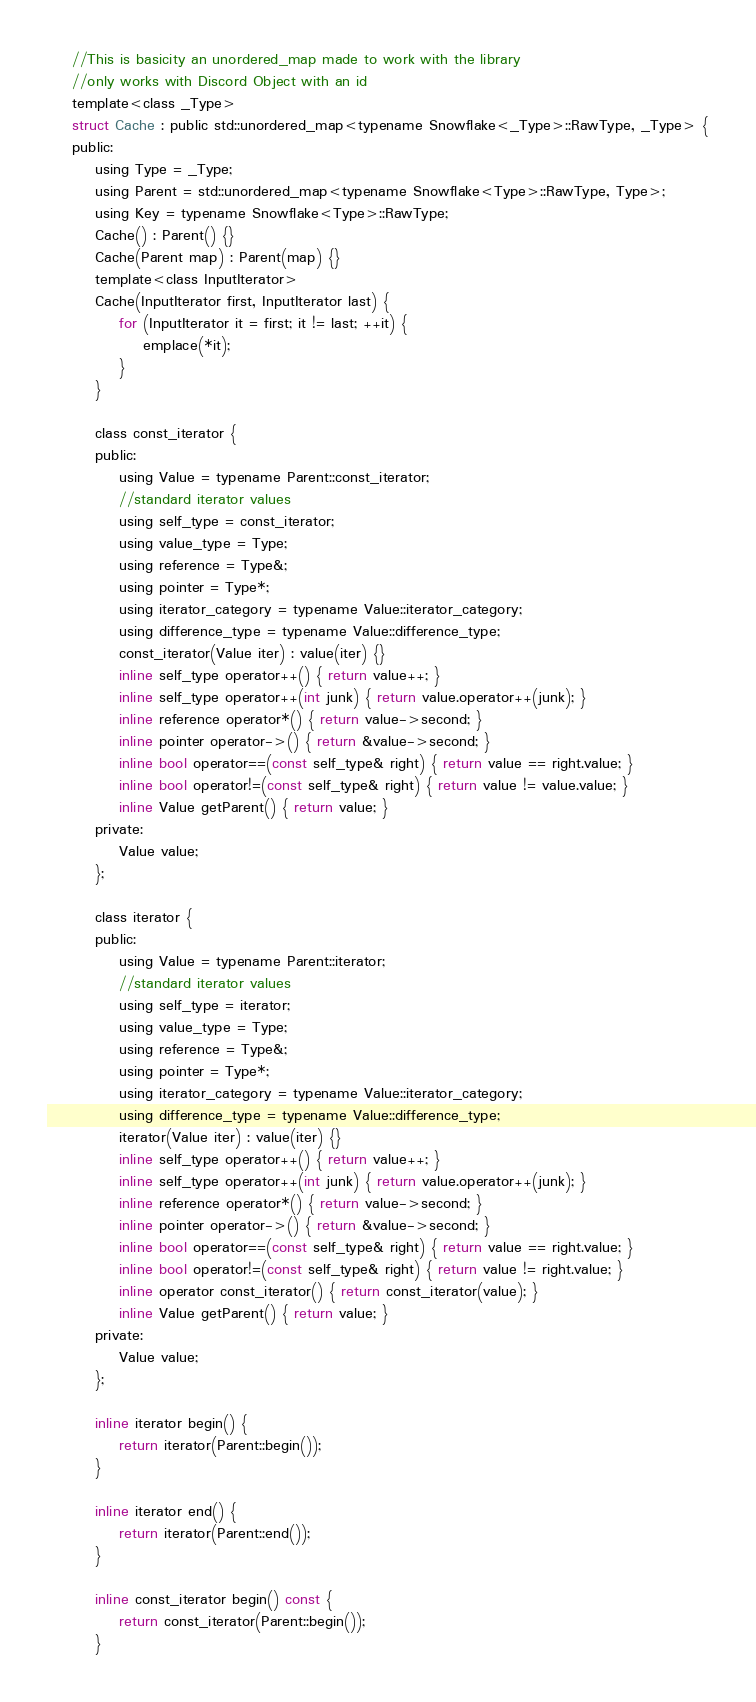Convert code to text. <code><loc_0><loc_0><loc_500><loc_500><_C_>	//This is basicity an unordered_map made to work with the library
	//only works with Discord Object with an id
	template<class _Type>
	struct Cache : public std::unordered_map<typename Snowflake<_Type>::RawType, _Type> {
	public:
		using Type = _Type;
		using Parent = std::unordered_map<typename Snowflake<Type>::RawType, Type>;
		using Key = typename Snowflake<Type>::RawType;
		Cache() : Parent() {}
		Cache(Parent map) : Parent(map) {}
		template<class InputIterator>
		Cache(InputIterator first, InputIterator last) {
			for (InputIterator it = first; it != last; ++it) {
				emplace(*it);
			}
		}

		class const_iterator {
		public:
			using Value = typename Parent::const_iterator;
			//standard iterator values
			using self_type = const_iterator;
			using value_type = Type;
			using reference = Type&;
			using pointer = Type*;
			using iterator_category = typename Value::iterator_category;
			using difference_type = typename Value::difference_type;
			const_iterator(Value iter) : value(iter) {}
			inline self_type operator++() { return value++; }
			inline self_type operator++(int junk) { return value.operator++(junk); }
			inline reference operator*() { return value->second; }
			inline pointer operator->() { return &value->second; }
			inline bool operator==(const self_type& right) { return value == right.value; }
			inline bool operator!=(const self_type& right) { return value != value.value; }
			inline Value getParent() { return value; }
		private:
			Value value;
		};

		class iterator {
		public:
			using Value = typename Parent::iterator;
			//standard iterator values
			using self_type = iterator;
			using value_type = Type;
			using reference = Type&;
			using pointer = Type*;
			using iterator_category = typename Value::iterator_category;
			using difference_type = typename Value::difference_type;
			iterator(Value iter) : value(iter) {}
			inline self_type operator++() { return value++; }
			inline self_type operator++(int junk) { return value.operator++(junk); }
			inline reference operator*() { return value->second; }
			inline pointer operator->() { return &value->second; }
			inline bool operator==(const self_type& right) { return value == right.value; }
			inline bool operator!=(const self_type& right) { return value != right.value; }
			inline operator const_iterator() { return const_iterator(value); }
			inline Value getParent() { return value; }
		private:
			Value value;
		};

		inline iterator begin() {
			return iterator(Parent::begin());
		}

		inline iterator end() {
			return iterator(Parent::end());
		}

		inline const_iterator begin() const {
			return const_iterator(Parent::begin());
		}
</code> 